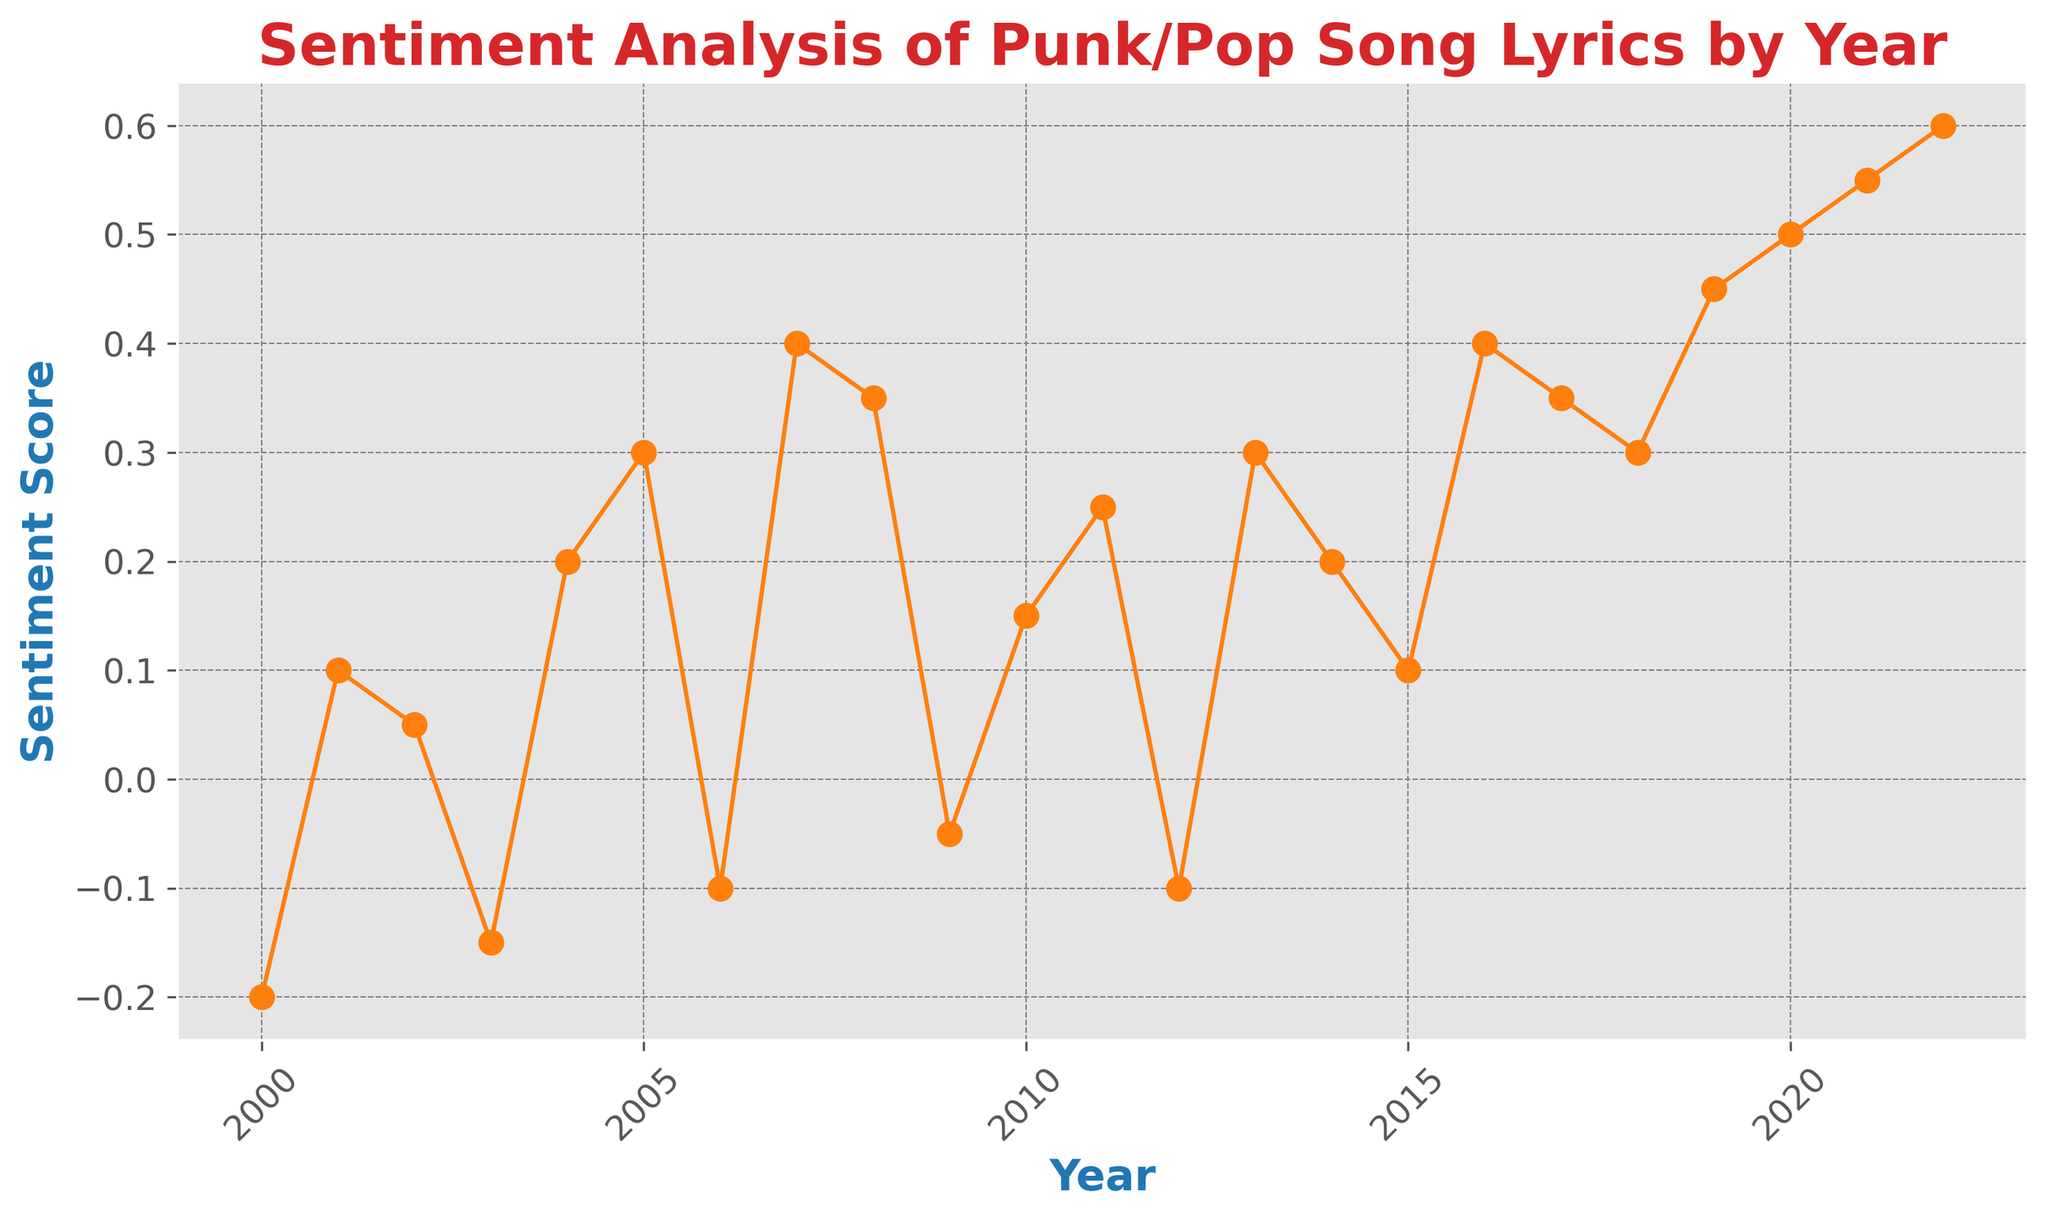What year had the highest sentiment score? Looking at the plot, the highest point on the vertical axis corresponds to the sentiment score of 0.6, which occurs in the year 2022.
Answer: 2022 How does the sentiment score in 2003 compare to 2005? The sentiment score in 2003 is -0.15, which is lower than the sentiment score of 0.3 in 2005.
Answer: 2005 is higher What is the approximate average sentiment score between 2015 and 2020? To find the average, sum the sentiment scores from 2015 to 2020 and divide by the number of years. The sentiment scores are 0.1, 0.4, 0.35, 0.3, 0.45, 0.5. Sum: 0.1 + 0.4 + 0.35 + 0.3 + 0.45 + 0.5 = 2.1. Average: 2.1 / 6 ≈ 0.35.
Answer: 0.35 What period exhibits the longest period of continuous growth in sentiment score? The longest continuous growth is observed from 2012 to 2022. The sentiment score consistently increases every year from -0.1 in 2012 to 0.6 in 2022.
Answer: 2012-2022 Does the sentiment score always increase year by year from 2014 to 2022? By examining the plot, we notice that although there's a general increase, the sentiment does not grow consistently every year. For instance, the sentiment score decreases from 2015 (0.1) to 2016 (0.4).
Answer: No Which year witnessed a significant drop in sentiment score compared to its previous year? The year 2009 witnessed a significant drop in sentiment score from 0.35 in 2008 to -0.05.
Answer: 2009 What is the difference in the sentiment score between 2000 and 2022? To find the difference: sentiment score in 2022 (0.6) minus sentiment score in 2000 (-0.2). 0.6 - (-0.2) = 0.6 + 0.2 = 0.8.
Answer: 0.8 What years have negative sentiment scores? Looking at the plot, the years with negative sentiment scores are 2000, 2003, 2006, 2009, and 2012.
Answer: 2000, 2003, 2006, 2009, 2012 What is the overall trend in the sentiment score from 2000 to 2022? Observing the plot, there is a general upward trend from 2000 to 2022. Despite some fluctuations, the overall sentiment score rises from -0.2 to 0.6 over this period.
Answer: Upward trend 